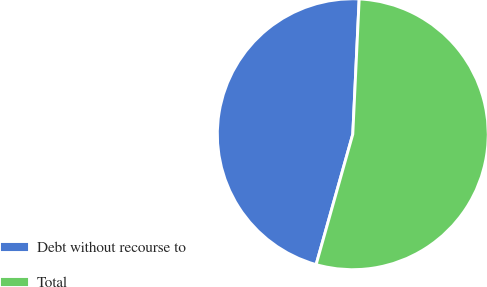<chart> <loc_0><loc_0><loc_500><loc_500><pie_chart><fcel>Debt without recourse to<fcel>Total<nl><fcel>46.39%<fcel>53.61%<nl></chart> 